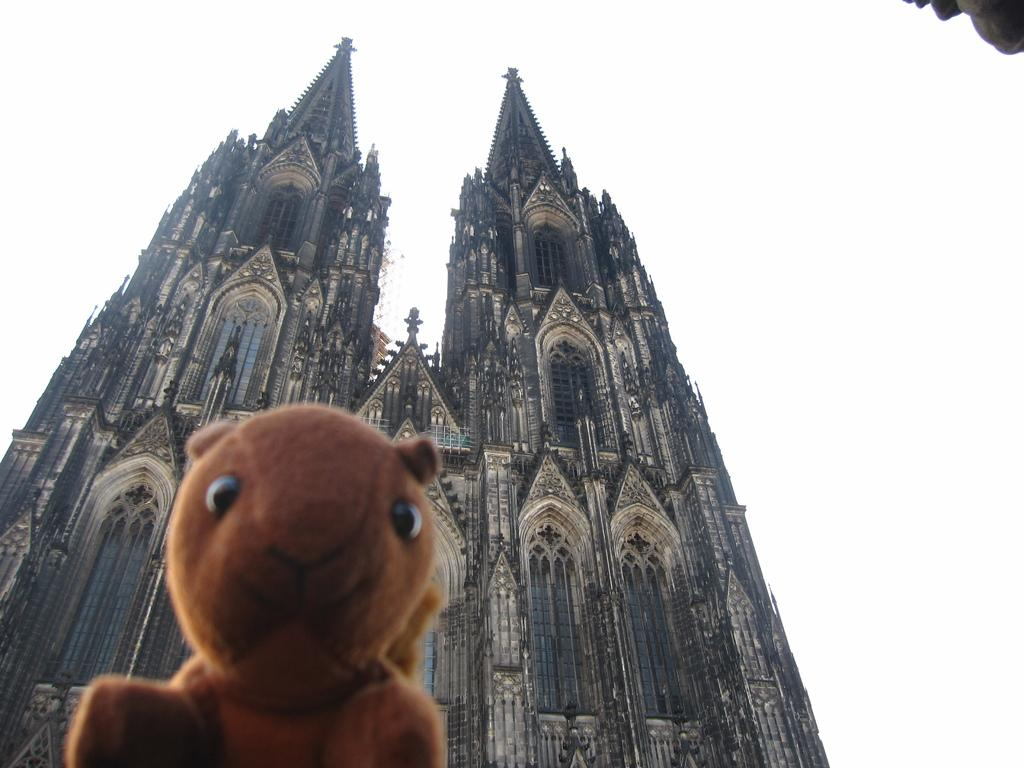What type of object can be seen in the image? There is a soft toy in the image. What can be seen in the distance behind the soft toy? There are buildings in the background of the image. Is there any rain or sleet falling on the soft toy in the image? There is no indication of rain or sleet in the image; it appears to be a dry environment. 